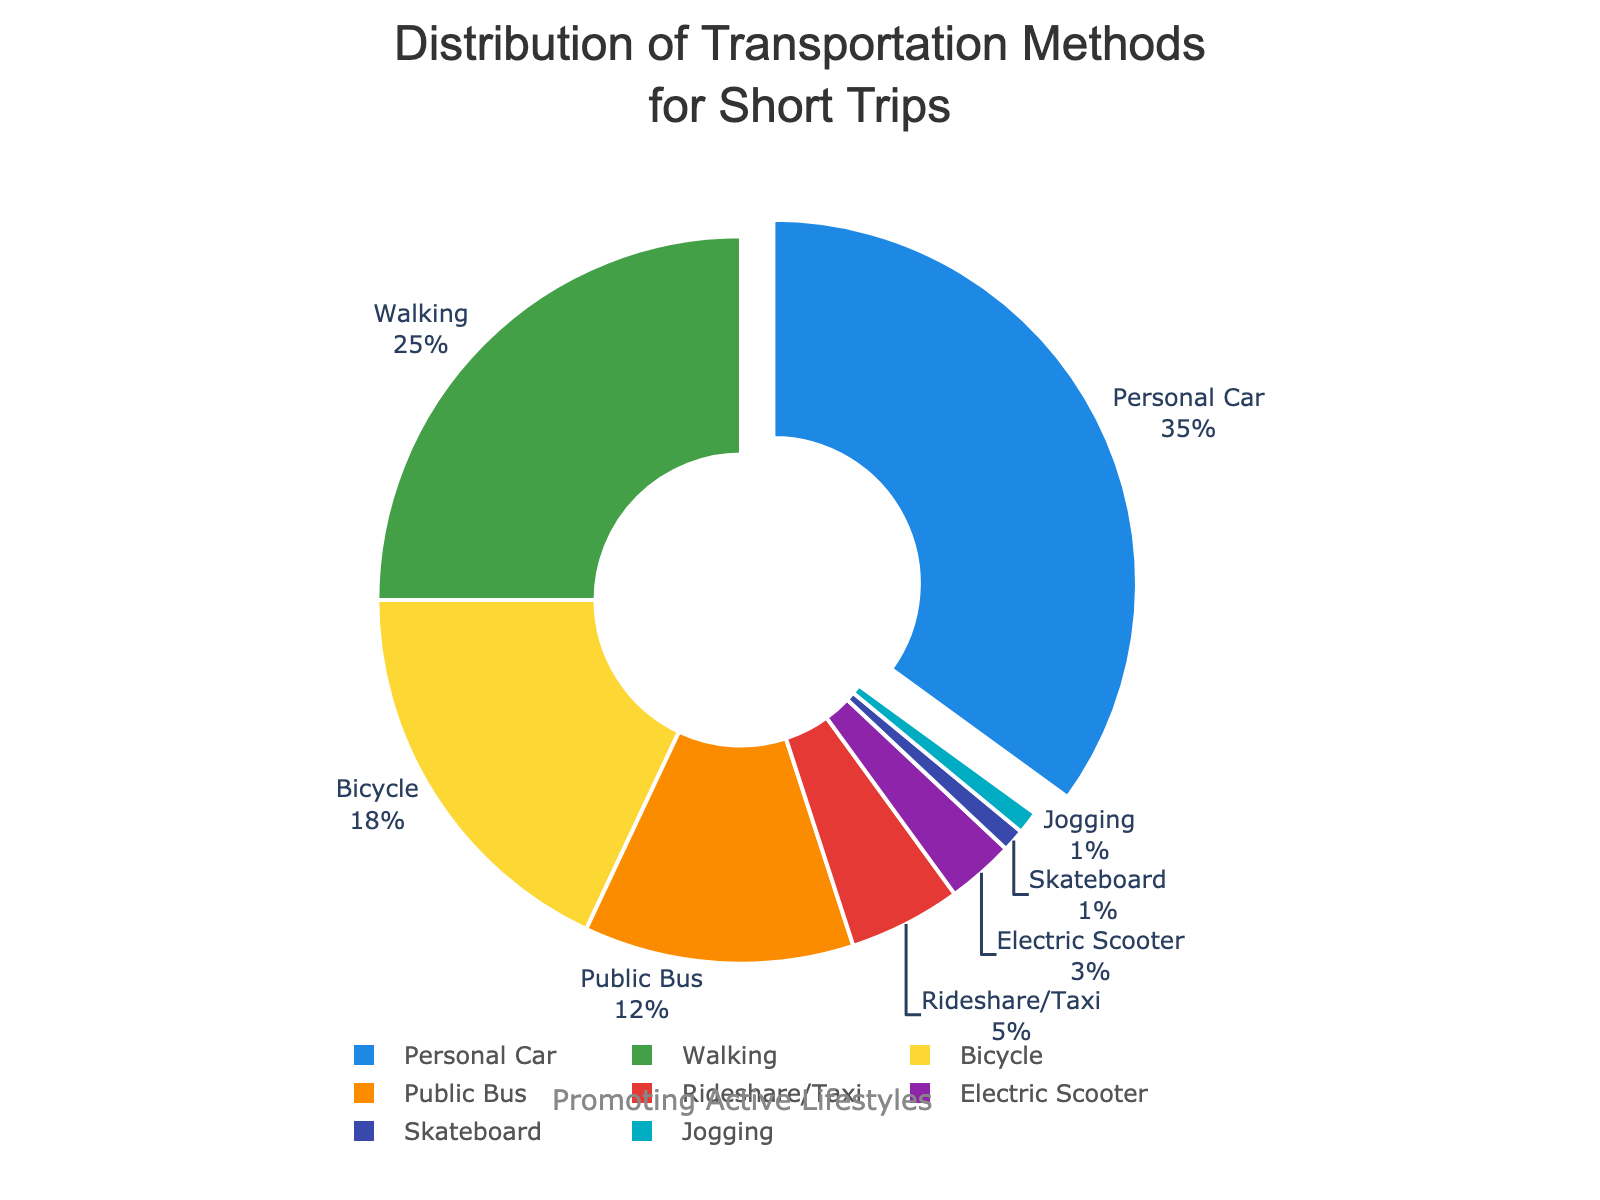Which transportation method is used most frequently for short trips? The pie chart highlights the slice with the highest percentage pulled away from the center. Here, the 'Personal Car' slice is pulled out, indicating it has the highest usage percentage.
Answer: Personal Car What is the combined percentage of walking and bicycling for short trips? Refer to the pie chart segments for 'Walking' and 'Bicycle.' Walking has 25% and Bicycling has 18%. Adding these percentages gives 25% + 18% = 43%.
Answer: 43% Which transportation method has the second lowest usage percentage, and what is its value? Examine the pie chart slices to determine the smallest slices after the least used. The least used, 'Skateboard' and 'Jogging,' each have 1%. The next smallest slice is 'Electric Scooter' with 3%.
Answer: Electric Scooter, 3% How much higher is the usage of public bus transportation compared to rideshare/taxi for short trips? The pie chart indicates 'Public Bus' at 12% and 'Rideshare/Taxi' at 5%. Subtract these values to find the difference: 12% - 5% = 7%.
Answer: 7% Which two transportation methods combined constitute more than half of the total transportation usage? Look at the largest slices in the pie chart. 'Personal Car' at 35% and 'Walking' at 25%. Together, they make up 35% + 25% = 60%, which is more than half.
Answer: Personal Car and Walking What is the percentage difference between the most and least used transportation methods? Identify the most used 'Personal Car' at 35% and the least used 'Skateboard' and 'Jogging' each at 1%. The difference is 35% - 1% = 34%.
Answer: 34% How many percentage points do public bus and electric scooter usage add up to? Check the slices for 'Public Bus' and 'Electric Scooter.' 'Public Bus' is at 12% and 'Electric Scooter' is at 3%. Adding these percentages gives 12% + 3% = 15%.
Answer: 15% What proportion of short trips are made using rideshare/taxi and jogging combined? From the pie chart, 'Rideshare/Taxi' is 5% and 'Jogging' is 1%. Adding these percentages gives 5% + 1% = 6%.
Answer: 6% If we consider only active transportation methods, what is the total percentage? As active methods, consider 'Walking' (25%), 'Bicycle' (18%), 'Jogging' (1%), and 'Skateboard' (1%). Adding these percentages: 25% + 18% + 1% + 1% = 45%.
Answer: 45% What percentage is used by all motorized methods combined (Personal Car, Public Bus, Rideshare/Taxi, and Electric Scooter)? From the pie chart, identify the motorized methods: 'Personal Car' (35%), 'Public Bus' (12%), 'Rideshare/Taxi' (5%), and 'Electric Scooter' (3%). Adding these gives 35% + 12% + 5% + 3% = 55%.
Answer: 55% 